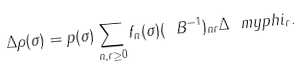<formula> <loc_0><loc_0><loc_500><loc_500>\Delta \rho ( \sigma ) = p ( \sigma ) \sum _ { n , r \geq 0 } f _ { n } ( \sigma ) ( \ B ^ { - 1 } ) _ { n r } \Delta \ m y p h i _ { r } .</formula> 